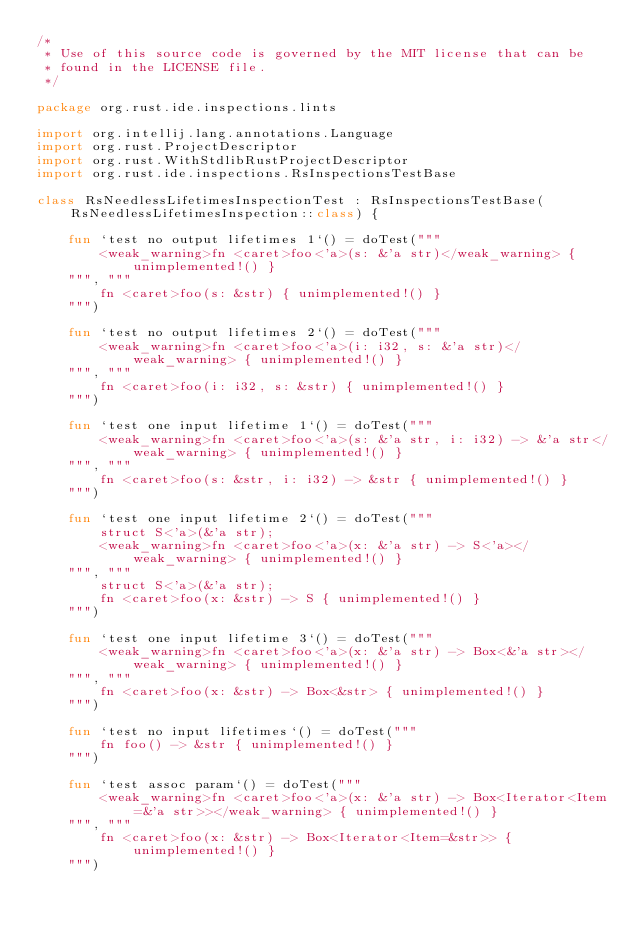<code> <loc_0><loc_0><loc_500><loc_500><_Kotlin_>/*
 * Use of this source code is governed by the MIT license that can be
 * found in the LICENSE file.
 */

package org.rust.ide.inspections.lints

import org.intellij.lang.annotations.Language
import org.rust.ProjectDescriptor
import org.rust.WithStdlibRustProjectDescriptor
import org.rust.ide.inspections.RsInspectionsTestBase

class RsNeedlessLifetimesInspectionTest : RsInspectionsTestBase(RsNeedlessLifetimesInspection::class) {

    fun `test no output lifetimes 1`() = doTest("""
        <weak_warning>fn <caret>foo<'a>(s: &'a str)</weak_warning> { unimplemented!() }
    """, """
        fn <caret>foo(s: &str) { unimplemented!() }
    """)

    fun `test no output lifetimes 2`() = doTest("""
        <weak_warning>fn <caret>foo<'a>(i: i32, s: &'a str)</weak_warning> { unimplemented!() }
    """, """
        fn <caret>foo(i: i32, s: &str) { unimplemented!() }
    """)

    fun `test one input lifetime 1`() = doTest("""
        <weak_warning>fn <caret>foo<'a>(s: &'a str, i: i32) -> &'a str</weak_warning> { unimplemented!() }
    """, """
        fn <caret>foo(s: &str, i: i32) -> &str { unimplemented!() }
    """)

    fun `test one input lifetime 2`() = doTest("""
        struct S<'a>(&'a str);
        <weak_warning>fn <caret>foo<'a>(x: &'a str) -> S<'a></weak_warning> { unimplemented!() }
    """, """
        struct S<'a>(&'a str);
        fn <caret>foo(x: &str) -> S { unimplemented!() }
    """)

    fun `test one input lifetime 3`() = doTest("""
        <weak_warning>fn <caret>foo<'a>(x: &'a str) -> Box<&'a str></weak_warning> { unimplemented!() }
    """, """
        fn <caret>foo(x: &str) -> Box<&str> { unimplemented!() }
    """)

    fun `test no input lifetimes`() = doTest("""
        fn foo() -> &str { unimplemented!() }
    """)

    fun `test assoc param`() = doTest("""
        <weak_warning>fn <caret>foo<'a>(x: &'a str) -> Box<Iterator<Item=&'a str>></weak_warning> { unimplemented!() }
    """, """
        fn <caret>foo(x: &str) -> Box<Iterator<Item=&str>> { unimplemented!() }
    """)
</code> 